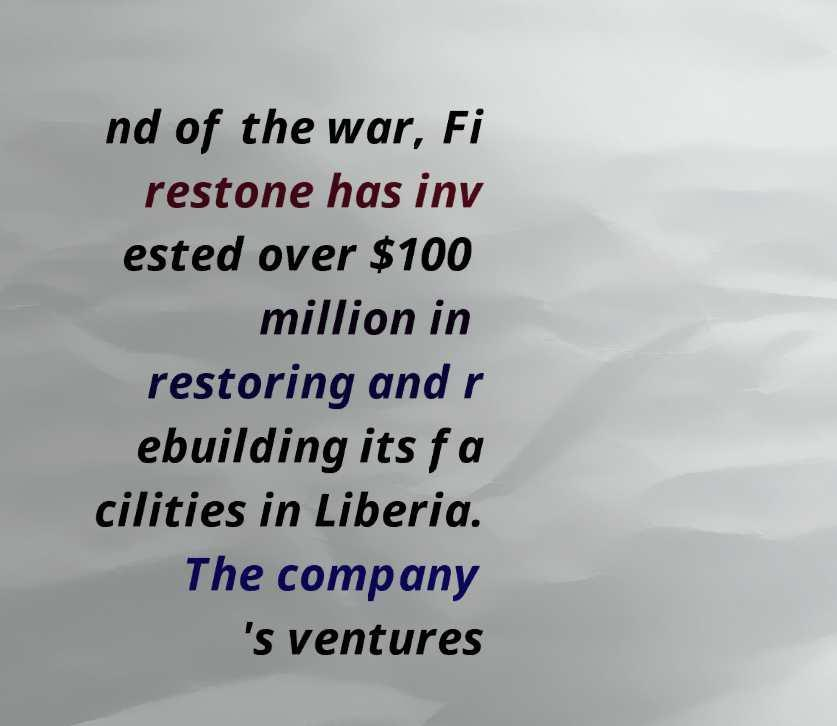Can you read and provide the text displayed in the image?This photo seems to have some interesting text. Can you extract and type it out for me? nd of the war, Fi restone has inv ested over $100 million in restoring and r ebuilding its fa cilities in Liberia. The company 's ventures 